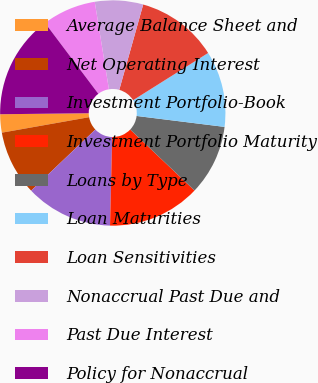Convert chart. <chart><loc_0><loc_0><loc_500><loc_500><pie_chart><fcel>Average Balance Sheet and<fcel>Net Operating Interest<fcel>Investment Portfolio-Book<fcel>Investment Portfolio Maturity<fcel>Loans by Type<fcel>Loan Maturities<fcel>Loan Sensitivities<fcel>Nonaccrual Past Due and<fcel>Past Due Interest<fcel>Policy for Nonaccrual<nl><fcel>2.62%<fcel>9.31%<fcel>12.51%<fcel>13.31%<fcel>10.11%<fcel>10.91%<fcel>11.71%<fcel>6.91%<fcel>7.71%<fcel>14.91%<nl></chart> 